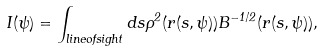<formula> <loc_0><loc_0><loc_500><loc_500>I ( \psi ) = \int _ { l i n e o f s i g h t } d s \rho ^ { 2 } ( r ( s , \psi ) ) B ^ { - 1 / 2 } ( r ( s , \psi ) ) ,</formula> 